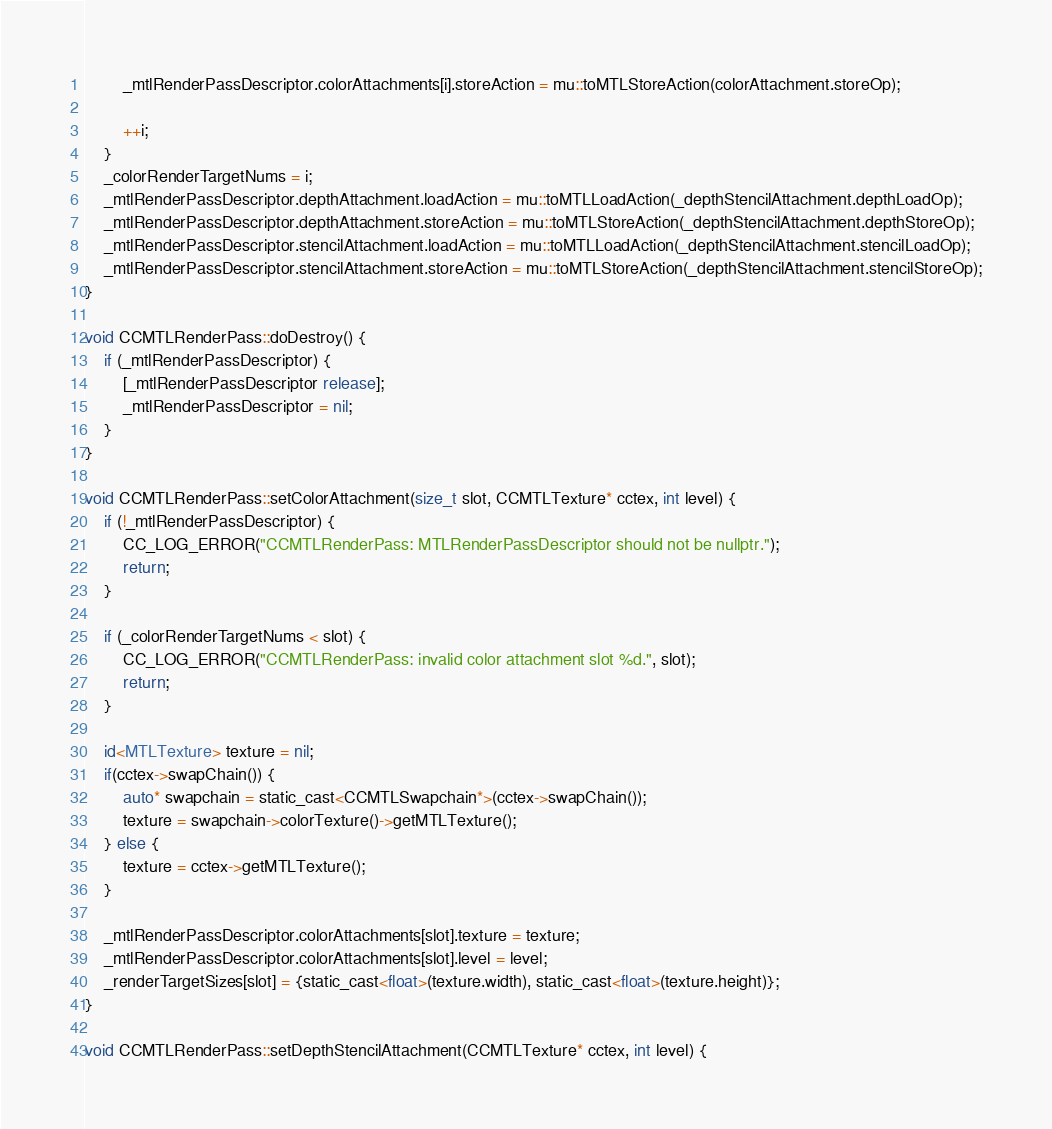<code> <loc_0><loc_0><loc_500><loc_500><_ObjectiveC_>        _mtlRenderPassDescriptor.colorAttachments[i].storeAction = mu::toMTLStoreAction(colorAttachment.storeOp);

        ++i;
    }
    _colorRenderTargetNums = i;
    _mtlRenderPassDescriptor.depthAttachment.loadAction = mu::toMTLLoadAction(_depthStencilAttachment.depthLoadOp);
    _mtlRenderPassDescriptor.depthAttachment.storeAction = mu::toMTLStoreAction(_depthStencilAttachment.depthStoreOp);
    _mtlRenderPassDescriptor.stencilAttachment.loadAction = mu::toMTLLoadAction(_depthStencilAttachment.stencilLoadOp);
    _mtlRenderPassDescriptor.stencilAttachment.storeAction = mu::toMTLStoreAction(_depthStencilAttachment.stencilStoreOp);
}

void CCMTLRenderPass::doDestroy() {
    if (_mtlRenderPassDescriptor) {
        [_mtlRenderPassDescriptor release];
        _mtlRenderPassDescriptor = nil;
    }
}

void CCMTLRenderPass::setColorAttachment(size_t slot, CCMTLTexture* cctex, int level) {
    if (!_mtlRenderPassDescriptor) {
        CC_LOG_ERROR("CCMTLRenderPass: MTLRenderPassDescriptor should not be nullptr.");
        return;
    }

    if (_colorRenderTargetNums < slot) {
        CC_LOG_ERROR("CCMTLRenderPass: invalid color attachment slot %d.", slot);
        return;
    }

    id<MTLTexture> texture = nil;
    if(cctex->swapChain()) {
        auto* swapchain = static_cast<CCMTLSwapchain*>(cctex->swapChain());
        texture = swapchain->colorTexture()->getMTLTexture();
    } else {
        texture = cctex->getMTLTexture();
    }

    _mtlRenderPassDescriptor.colorAttachments[slot].texture = texture;
    _mtlRenderPassDescriptor.colorAttachments[slot].level = level;
    _renderTargetSizes[slot] = {static_cast<float>(texture.width), static_cast<float>(texture.height)};
}

void CCMTLRenderPass::setDepthStencilAttachment(CCMTLTexture* cctex, int level) {</code> 